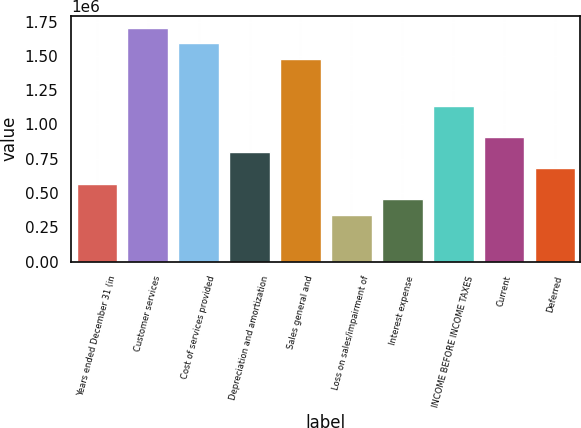Convert chart. <chart><loc_0><loc_0><loc_500><loc_500><bar_chart><fcel>Years ended December 31 (in<fcel>Customer services<fcel>Cost of services provided<fcel>Depreciation and amortization<fcel>Sales general and<fcel>Loss on sales/impairment of<fcel>Interest expense<fcel>INCOME BEFORE INCOME TAXES<fcel>Current<fcel>Deferred<nl><fcel>568445<fcel>1.70533e+06<fcel>1.59165e+06<fcel>795823<fcel>1.47796e+06<fcel>341067<fcel>454756<fcel>1.13689e+06<fcel>909512<fcel>682134<nl></chart> 